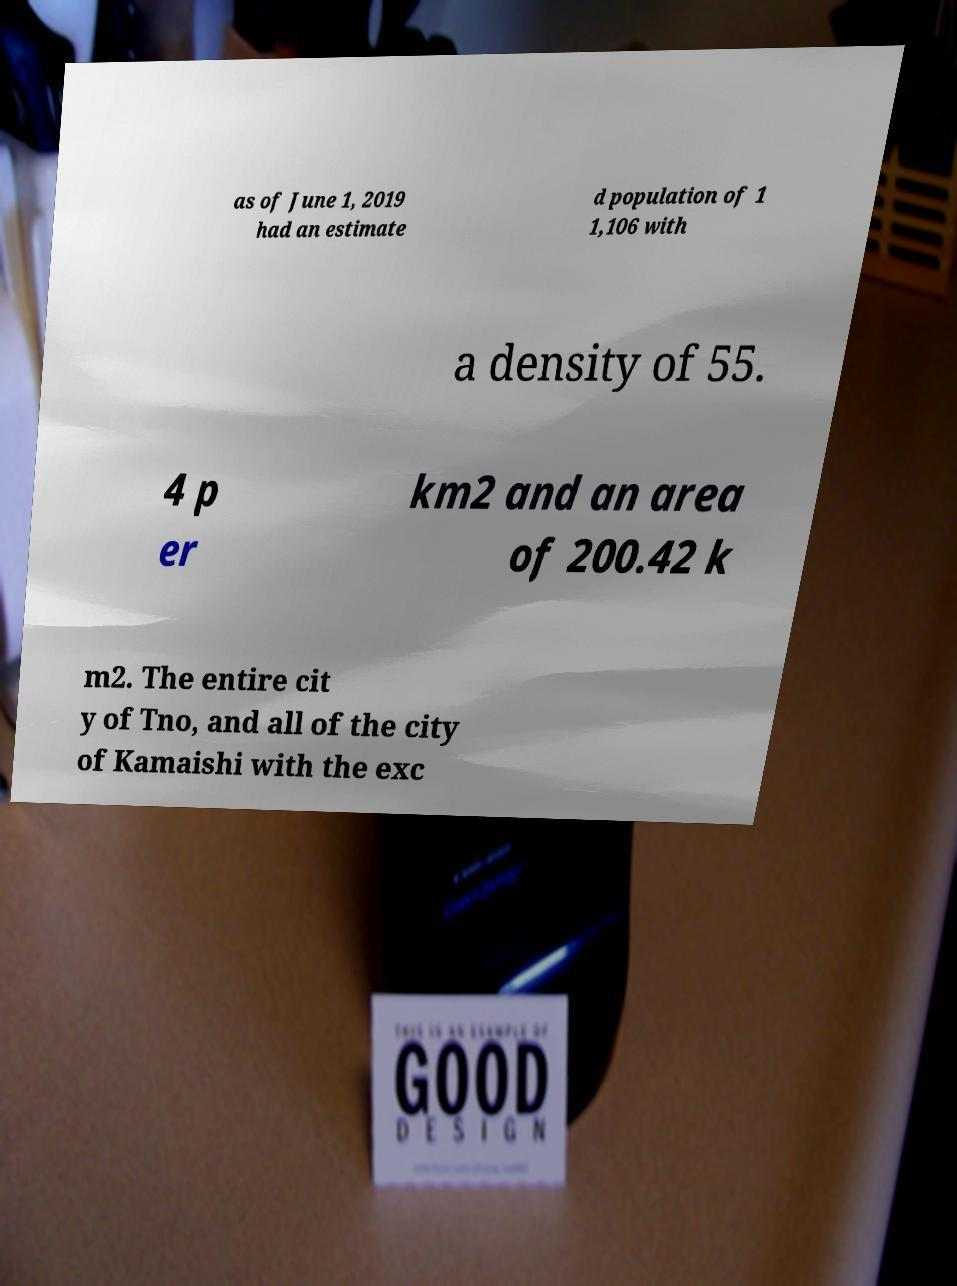Could you assist in decoding the text presented in this image and type it out clearly? as of June 1, 2019 had an estimate d population of 1 1,106 with a density of 55. 4 p er km2 and an area of 200.42 k m2. The entire cit y of Tno, and all of the city of Kamaishi with the exc 